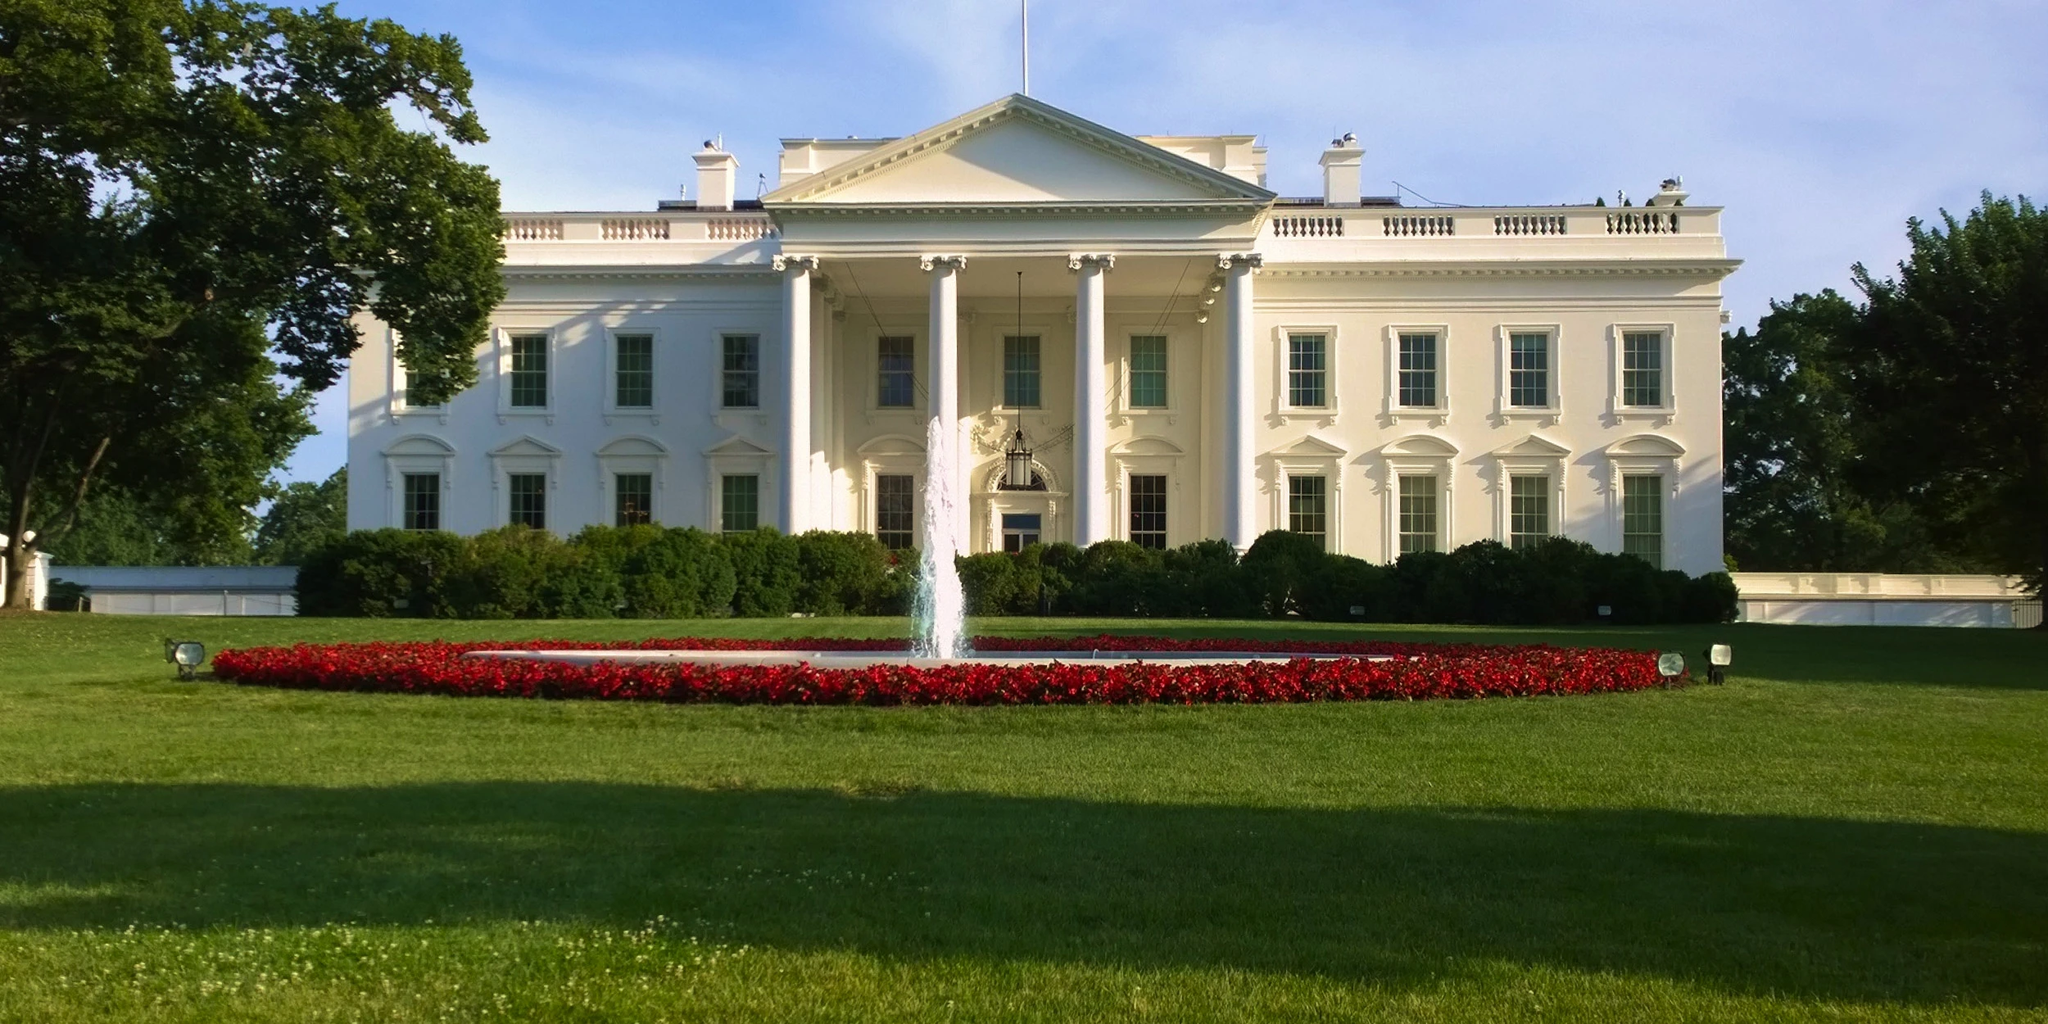Can you describe a casual day at the White House lawn? On a casual Sunday, the White House lawn is a scene of tranquility. The First Family might be seen enjoying a game of catch or taking a leisurely stroll. Staff and security members are discreetly present, maintaining the serene environment. Birds chirp from the surrounding trees, and the fountain's gentle spray creates a soothing background noise. Occasionally, a small group might attend an informal meeting outdoors, taking advantage of the pleasant weather while discussing official matters. The lawn offers a peaceful retreat from the bustling activities of the political world inside the White House. 